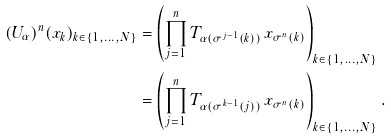Convert formula to latex. <formula><loc_0><loc_0><loc_500><loc_500>( U _ { \alpha } ) ^ { n } ( x _ { k } ) _ { k \in \{ 1 , \dots , N \} } & = \left ( \prod _ { j = 1 } ^ { n } T _ { \alpha ( \sigma ^ { j - 1 } ( k ) ) } \, x _ { \sigma ^ { n } ( k ) } \right ) _ { k \in \{ 1 , \dots , N \} } \\ & = \left ( \prod _ { j = 1 } ^ { n } T _ { \alpha ( \sigma ^ { k - 1 } ( j ) ) } \, x _ { \sigma ^ { n } ( k ) } \right ) _ { k \in \{ 1 , \dots , N \} } .</formula> 